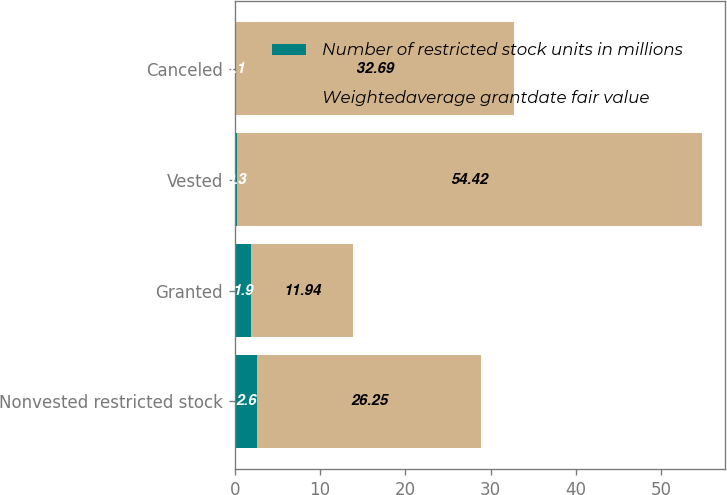Convert chart. <chart><loc_0><loc_0><loc_500><loc_500><stacked_bar_chart><ecel><fcel>Nonvested restricted stock<fcel>Granted<fcel>Vested<fcel>Canceled<nl><fcel>Number of restricted stock units in millions<fcel>2.6<fcel>1.9<fcel>0.3<fcel>0.1<nl><fcel>Weightedaverage grantdate fair value<fcel>26.25<fcel>11.94<fcel>54.42<fcel>32.69<nl></chart> 